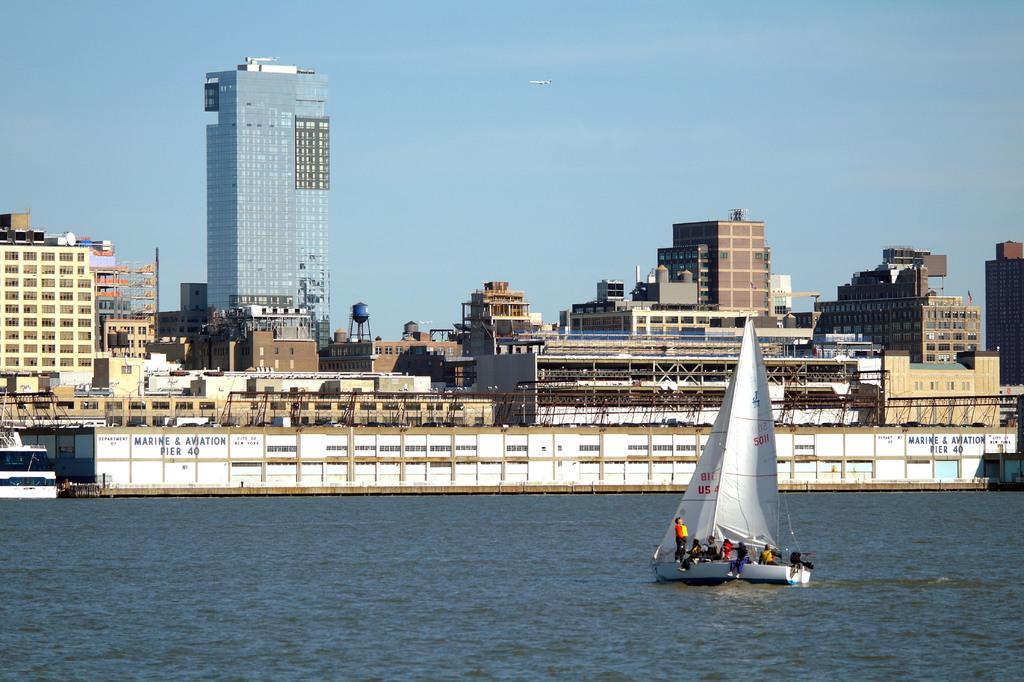In one or two sentences, can you explain what this image depicts? In this image we can see a few people sailing on the boat, which is on the water, there are some buildings, windows, also we can see the sky. 